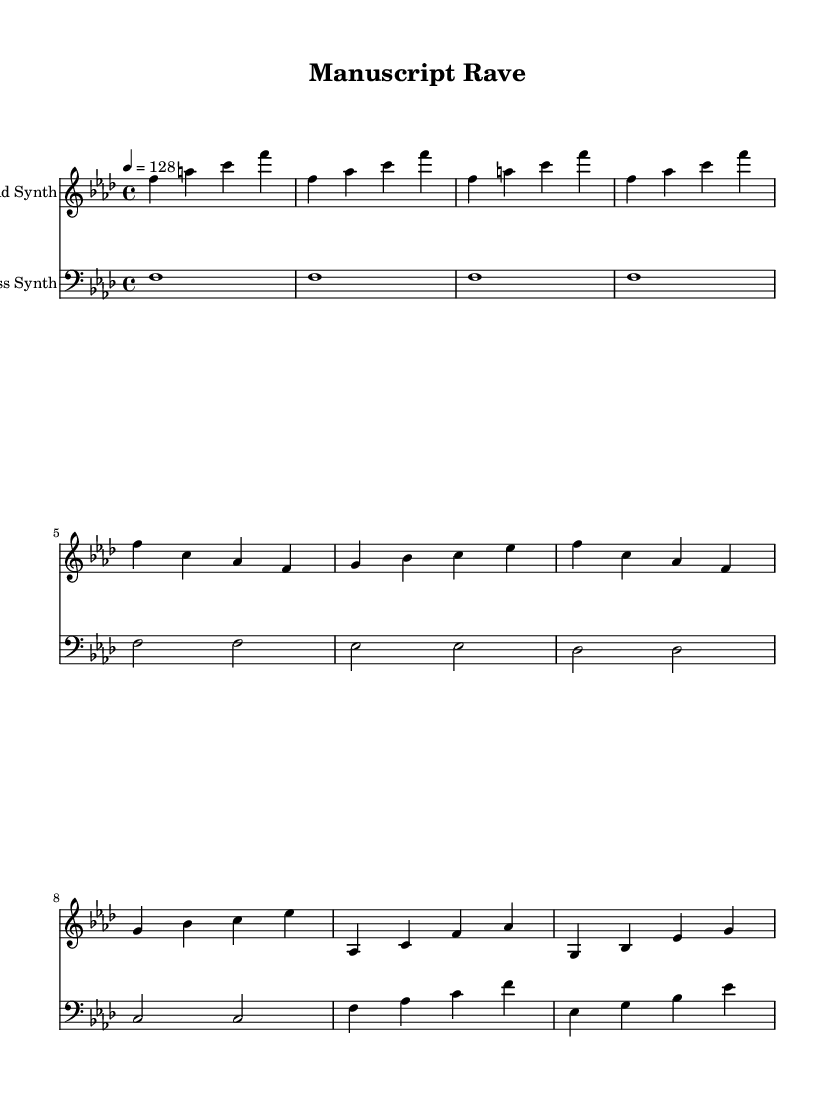What is the key signature of this music? The key signature is F minor, which has four flats (B♭, E♭, A♭, D♭). This can be deduced from the key indication at the beginning of the music staff, denoted by "f minor".
Answer: F minor What is the time signature of this music? The time signature is 4/4. It is indicated at the beginning of the score, showing that there are four beats in each measure and a quarter note receives one beat.
Answer: 4/4 What is the tempo marking for this piece? The tempo marking is indicated as "4 = 128", meaning that there are 128 beats per minute, with each beat represented by the quarter note.
Answer: 128 How many measures are in the main theme melody? The main theme melody consists of 8 measures. By counting the groups of four beats (measures) laid out in the notation, we can confirm that it covers a total of 8 measures.
Answer: 8 What is the name of the lead instrument in this piece? The lead instrument is labeled as "Lead Synth" at the start of its respective staff in the score.
Answer: Lead Synth What is the rhythm pattern in the bridge melody? The rhythm pattern in the bridge melody consists primarily of eighth and quarter notes, creating a lively and energetic feel, typical of electronic dance music.
Answer: Eighth and quarter notes Which section uses bass notes most heavily? The main theme bass section uses bass notes most heavily, characterized by sustained whole notes that underpin the harmonic framework of the piece.
Answer: Main theme bass 